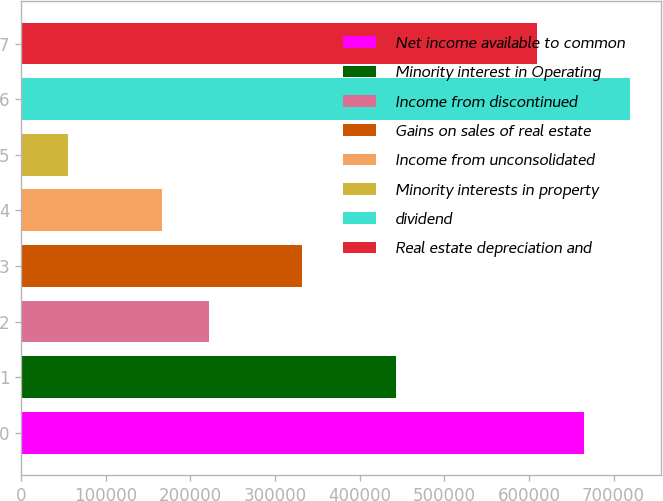<chart> <loc_0><loc_0><loc_500><loc_500><bar_chart><fcel>Net income available to common<fcel>Minority interest in Operating<fcel>Income from discontinued<fcel>Gains on sales of real estate<fcel>Income from unconsolidated<fcel>Minority interests in property<fcel>dividend<fcel>Real estate depreciation and<nl><fcel>664578<fcel>443080<fcel>221581<fcel>332331<fcel>166207<fcel>55457.6<fcel>719953<fcel>609204<nl></chart> 